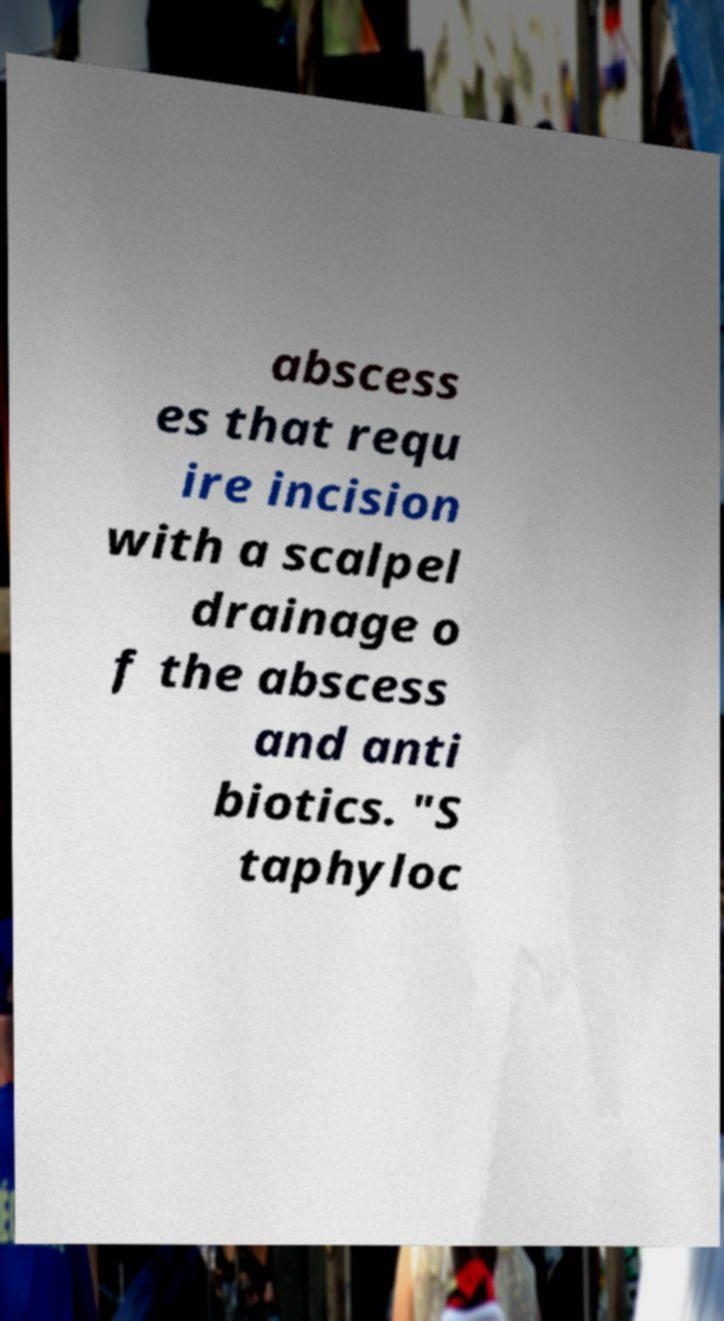For documentation purposes, I need the text within this image transcribed. Could you provide that? abscess es that requ ire incision with a scalpel drainage o f the abscess and anti biotics. "S taphyloc 